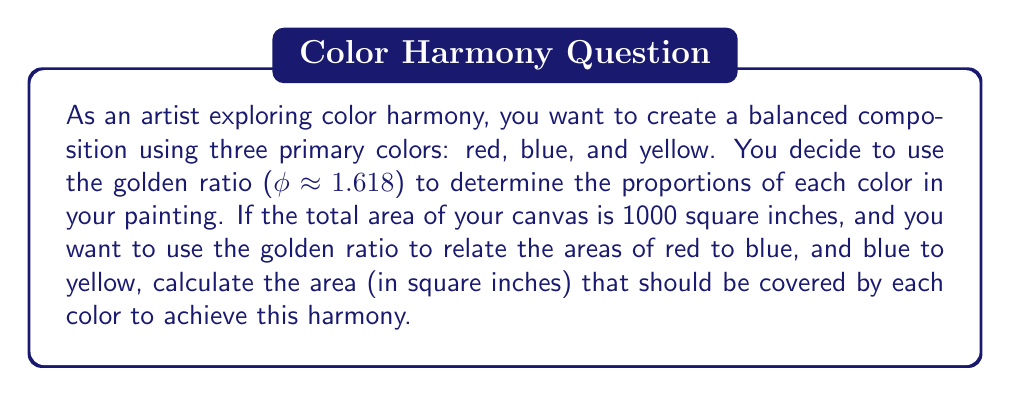Could you help me with this problem? Let's approach this step-by-step:

1) Let's denote the areas as:
   $R$ for red, $B$ for blue, and $Y$ for yellow

2) We know that the total area is 1000 square inches:
   $$R + B + Y = 1000$$

3) We want to use the golden ratio (φ) to relate the areas:
   $$\frac{R}{B} = \frac{B}{Y} = φ ≈ 1.618$$

4) From this, we can express R and Y in terms of B:
   $$R = 1.618B$$
   $$Y = \frac{B}{1.618}$$

5) Substituting these into our total area equation:
   $$1.618B + B + \frac{B}{1.618} = 1000$$

6) Simplifying:
   $$B(1.618 + 1 + \frac{1}{1.618}) = 1000$$
   $$B(1.618 + 1 + 0.618) = 1000$$
   $$B(3.236) = 1000$$

7) Solving for B:
   $$B = \frac{1000}{3.236} ≈ 309.02$$

8) Now we can calculate R and Y:
   $$R = 1.618B ≈ 1.618 * 309.02 ≈ 500.00$$
   $$Y = \frac{B}{1.618} ≈ \frac{309.02}{1.618} ≈ 190.98$$

9) Rounding to the nearest square inch:
   R ≈ 500 sq inches
   B ≈ 309 sq inches
   Y ≈ 191 sq inches
Answer: Red: 500 sq inches, Blue: 309 sq inches, Yellow: 191 sq inches 